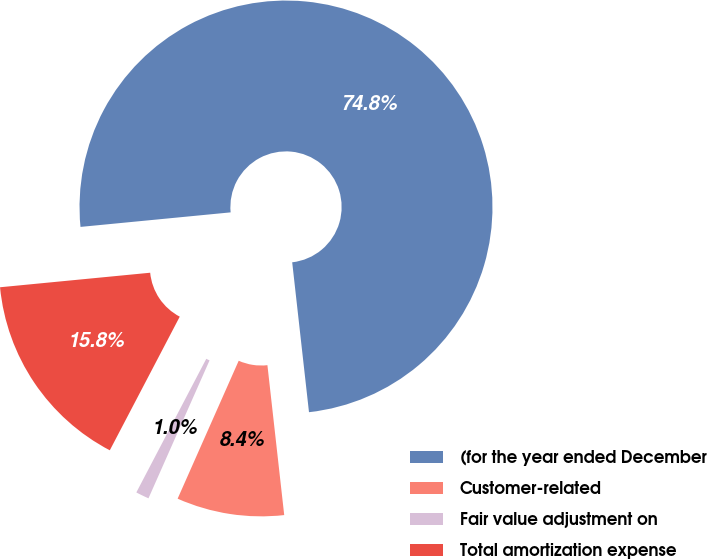Convert chart to OTSL. <chart><loc_0><loc_0><loc_500><loc_500><pie_chart><fcel>(for the year ended December<fcel>Customer-related<fcel>Fair value adjustment on<fcel>Total amortization expense<nl><fcel>74.76%<fcel>8.41%<fcel>1.04%<fcel>15.79%<nl></chart> 